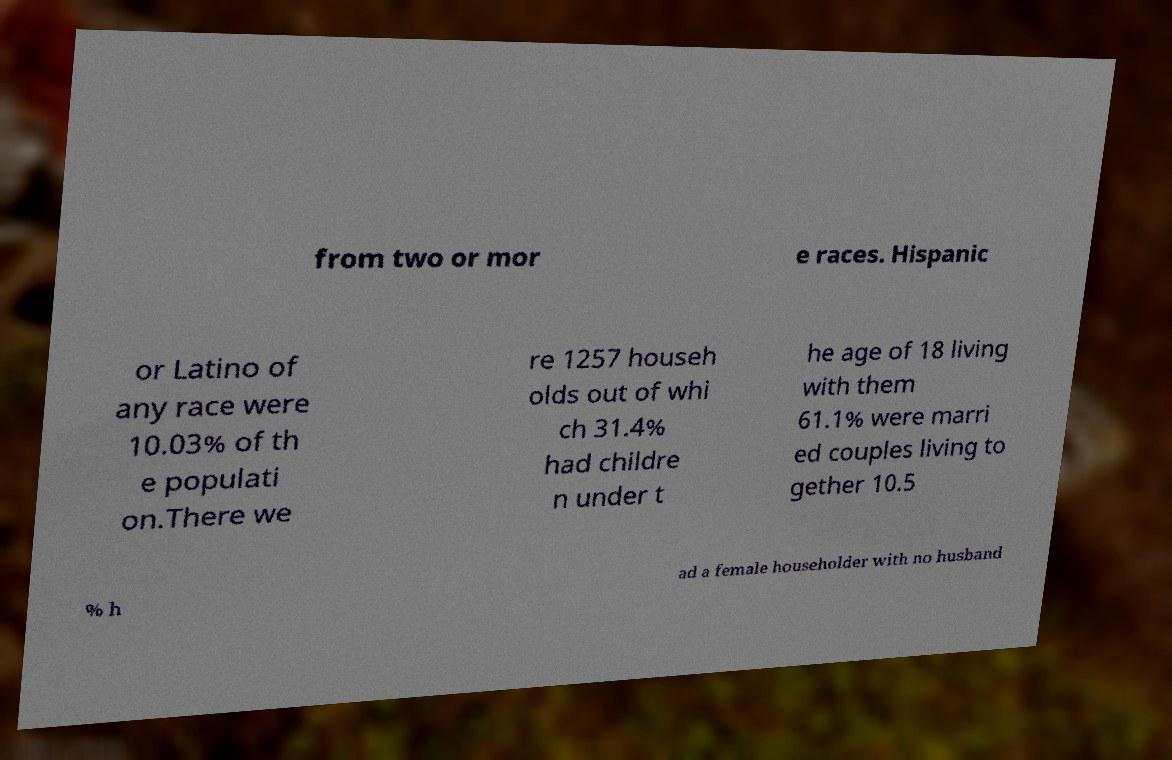Could you assist in decoding the text presented in this image and type it out clearly? from two or mor e races. Hispanic or Latino of any race were 10.03% of th e populati on.There we re 1257 househ olds out of whi ch 31.4% had childre n under t he age of 18 living with them 61.1% were marri ed couples living to gether 10.5 % h ad a female householder with no husband 